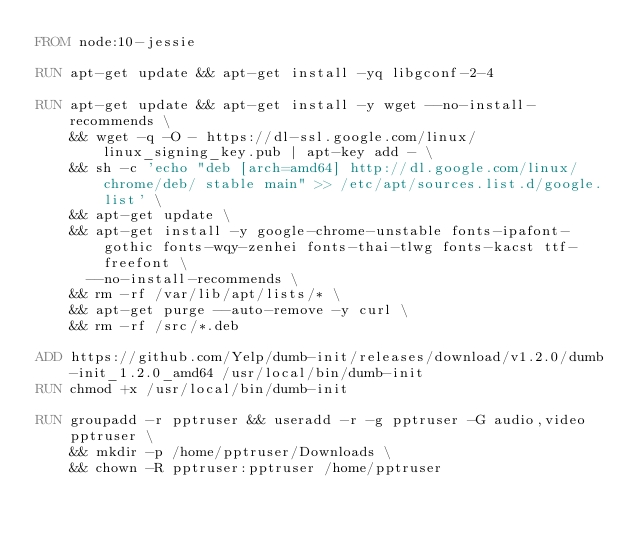Convert code to text. <code><loc_0><loc_0><loc_500><loc_500><_Dockerfile_>FROM node:10-jessie

RUN apt-get update && apt-get install -yq libgconf-2-4

RUN apt-get update && apt-get install -y wget --no-install-recommends \
    && wget -q -O - https://dl-ssl.google.com/linux/linux_signing_key.pub | apt-key add - \
    && sh -c 'echo "deb [arch=amd64] http://dl.google.com/linux/chrome/deb/ stable main" >> /etc/apt/sources.list.d/google.list' \
    && apt-get update \
    && apt-get install -y google-chrome-unstable fonts-ipafont-gothic fonts-wqy-zenhei fonts-thai-tlwg fonts-kacst ttf-freefont \
      --no-install-recommends \
    && rm -rf /var/lib/apt/lists/* \
    && apt-get purge --auto-remove -y curl \
    && rm -rf /src/*.deb

ADD https://github.com/Yelp/dumb-init/releases/download/v1.2.0/dumb-init_1.2.0_amd64 /usr/local/bin/dumb-init
RUN chmod +x /usr/local/bin/dumb-init

RUN groupadd -r pptruser && useradd -r -g pptruser -G audio,video pptruser \
    && mkdir -p /home/pptruser/Downloads \
    && chown -R pptruser:pptruser /home/pptruser
</code> 